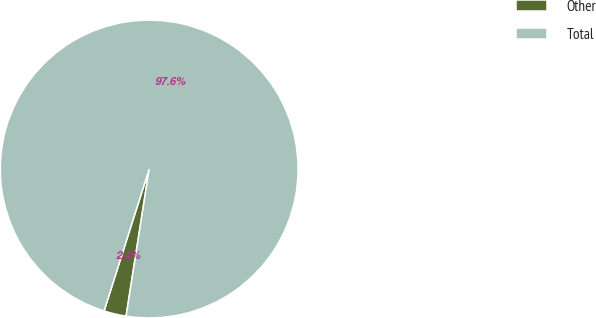<chart> <loc_0><loc_0><loc_500><loc_500><pie_chart><fcel>Other<fcel>Total<nl><fcel>2.42%<fcel>97.58%<nl></chart> 